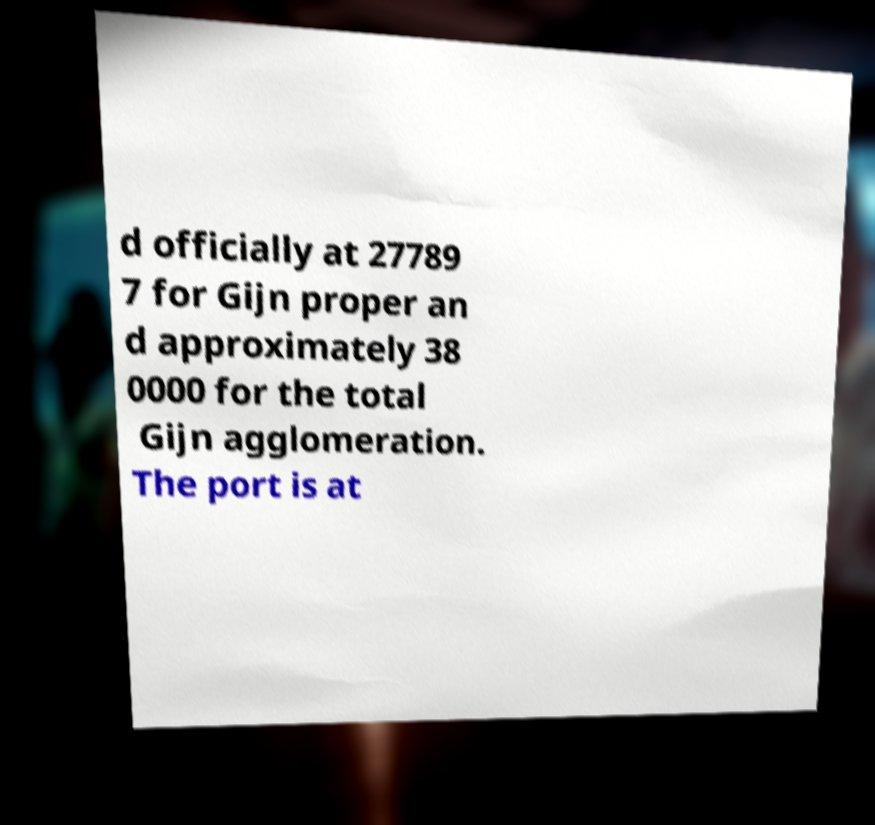Can you accurately transcribe the text from the provided image for me? d officially at 27789 7 for Gijn proper an d approximately 38 0000 for the total Gijn agglomeration. The port is at 